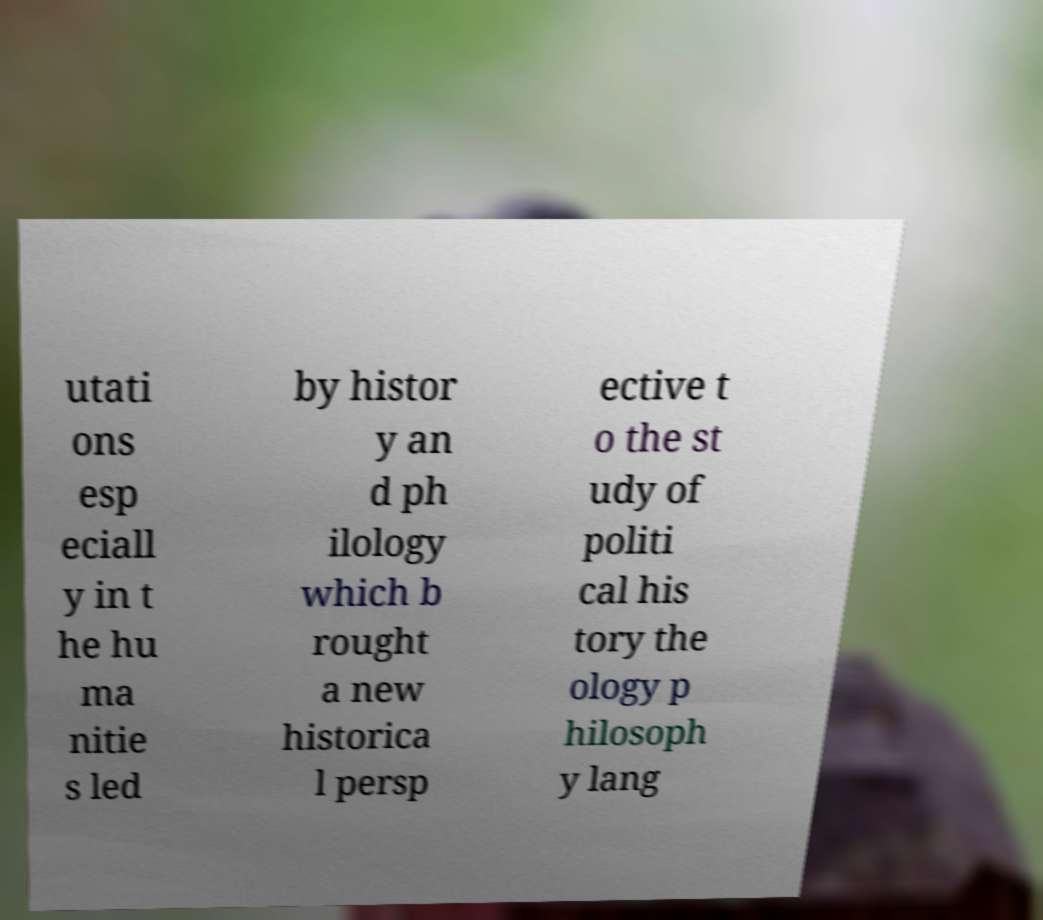Could you extract and type out the text from this image? utati ons esp eciall y in t he hu ma nitie s led by histor y an d ph ilology which b rought a new historica l persp ective t o the st udy of politi cal his tory the ology p hilosoph y lang 